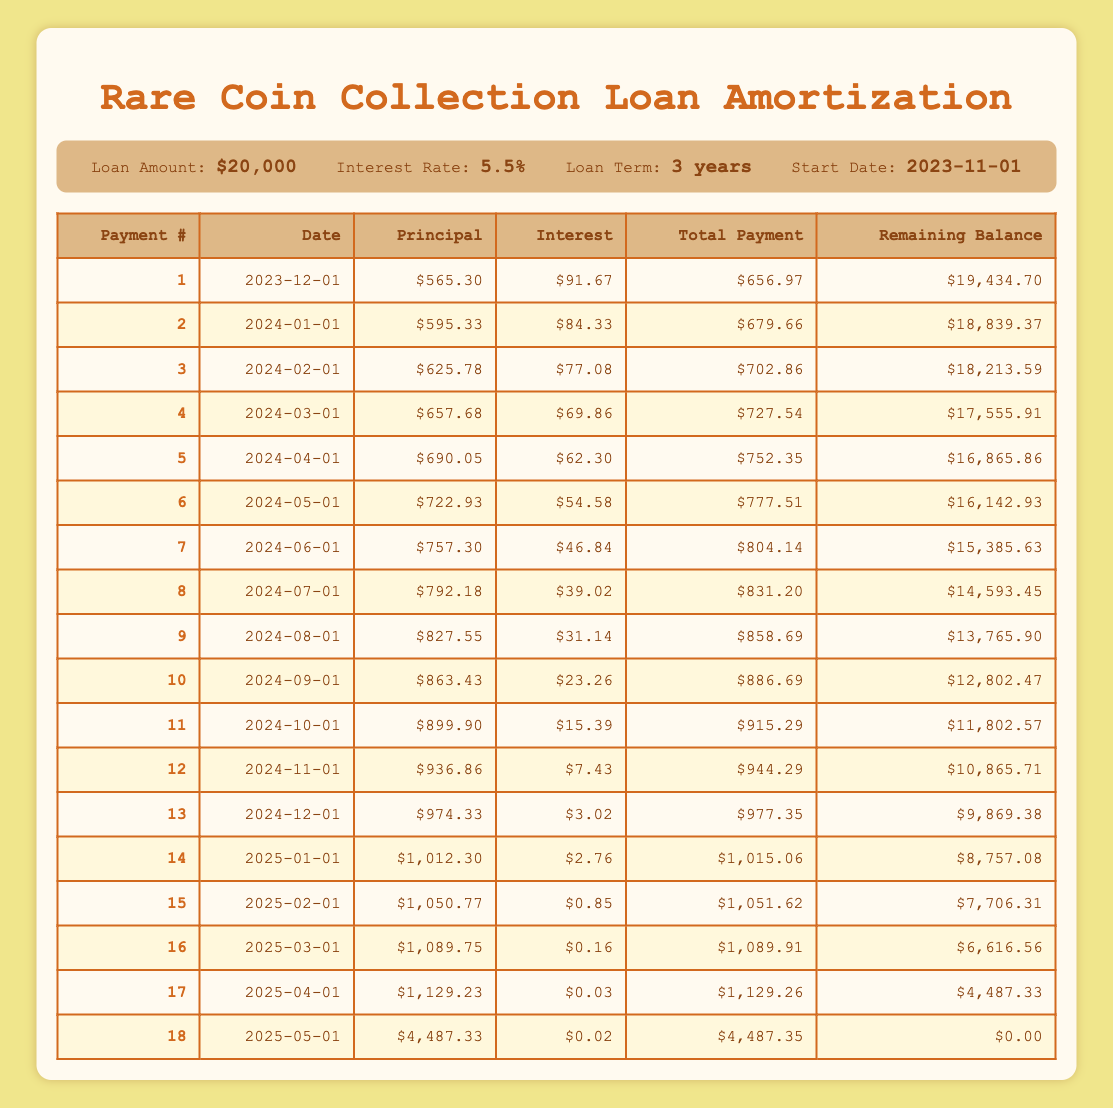What is the total payment for the first month? From the table, the total payment listed for the first month (2023-12-01) is $656.97.
Answer: 656.97 How much principal is paid off in the sixth payment? Referring to the sixth payment (2024-05-01), the principal payment is $722.93.
Answer: 722.93 What is the interest amount paid in the tenth payment? In the table for the tenth payment (2024-09-01), the interest payment is $23.26.
Answer: 23.26 What is the remaining loan balance after the first three payments? To find the remaining balance, look at the balance after the third payment (2024-02-01), which is $18,213.59.
Answer: 18213.59 How much interest is paid in total over the first six payments? We sum the interest payments from the first six months: 91.67 + 84.33 + 77.08 + 69.86 + 62.30 + 54.58 = 439.82.
Answer: 439.82 Is the total payment of the fourth month greater than the third month? The total payment for the fourth month (2024-03-01) is $727.54 and for the third month (2024-02-01) is $702.86. Since 727.54 is greater than 702.86, the answer is yes.
Answer: Yes Which payment has the highest principal payment, and what is that amount? Comparing the principal payments across all rows, the highest is in the eighteenth payment (2025-05-01) with $4,487.33.
Answer: 4487.33 How much total will be paid in interest by the end of the loan term? Calculate the total interest paid from all periods: Adding all interest payments from each row gives a total of $823.04 (91.67 + 84.33 + up to the last entry).
Answer: 823.04 Which payment has the least interest payment, and what is that amount? The least interest payment is in the fifteenth payment (2025-02-01) with an interest payment of $0.85.
Answer: 0.85 What is the average payment amount over the entire loan period? To find the average, sum all total payments and divide by the number of payments (18). Total sums to $14,952.35, average is $14,952.35 / 18 = $831.74.
Answer: 831.74 